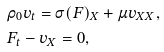Convert formula to latex. <formula><loc_0><loc_0><loc_500><loc_500>& \rho _ { 0 } v _ { t } = \sigma ( F ) _ { X } + \mu v _ { X X } , \\ & F _ { t } - v _ { X } = 0 ,</formula> 